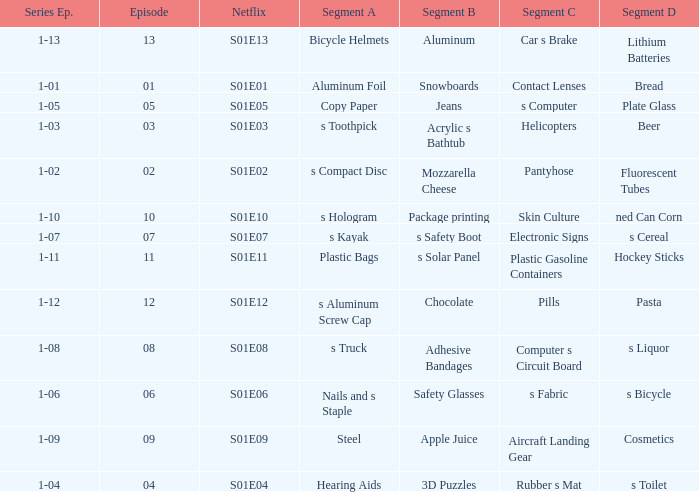What is the Netflix number having a series episode of 1-01? S01E01. 